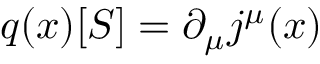Convert formula to latex. <formula><loc_0><loc_0><loc_500><loc_500>q ( x ) [ S ] = \partial _ { \mu } j ^ { \mu } ( x )</formula> 